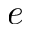<formula> <loc_0><loc_0><loc_500><loc_500>e</formula> 